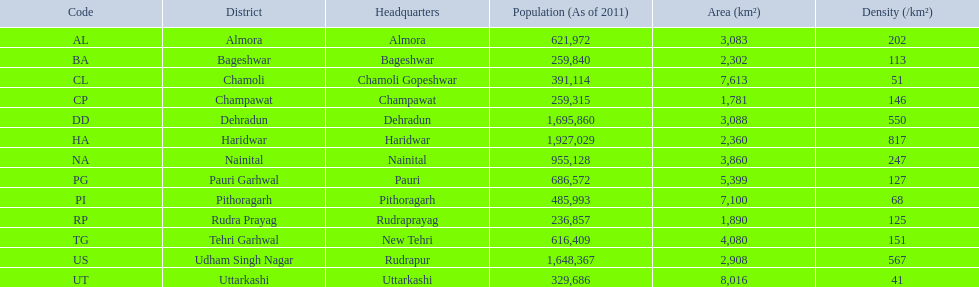What are the different districts? Almora, Bageshwar, Chamoli, Champawat, Dehradun, Haridwar, Nainital, Pauri Garhwal, Pithoragarh, Rudra Prayag, Tehri Garhwal, Udham Singh Nagar, Uttarkashi. And their density levels? 202, 113, 51, 146, 550, 817, 247, 127, 68, 125, 151, 567, 41. At present, which district possesses a density of 51? Chamoli. 